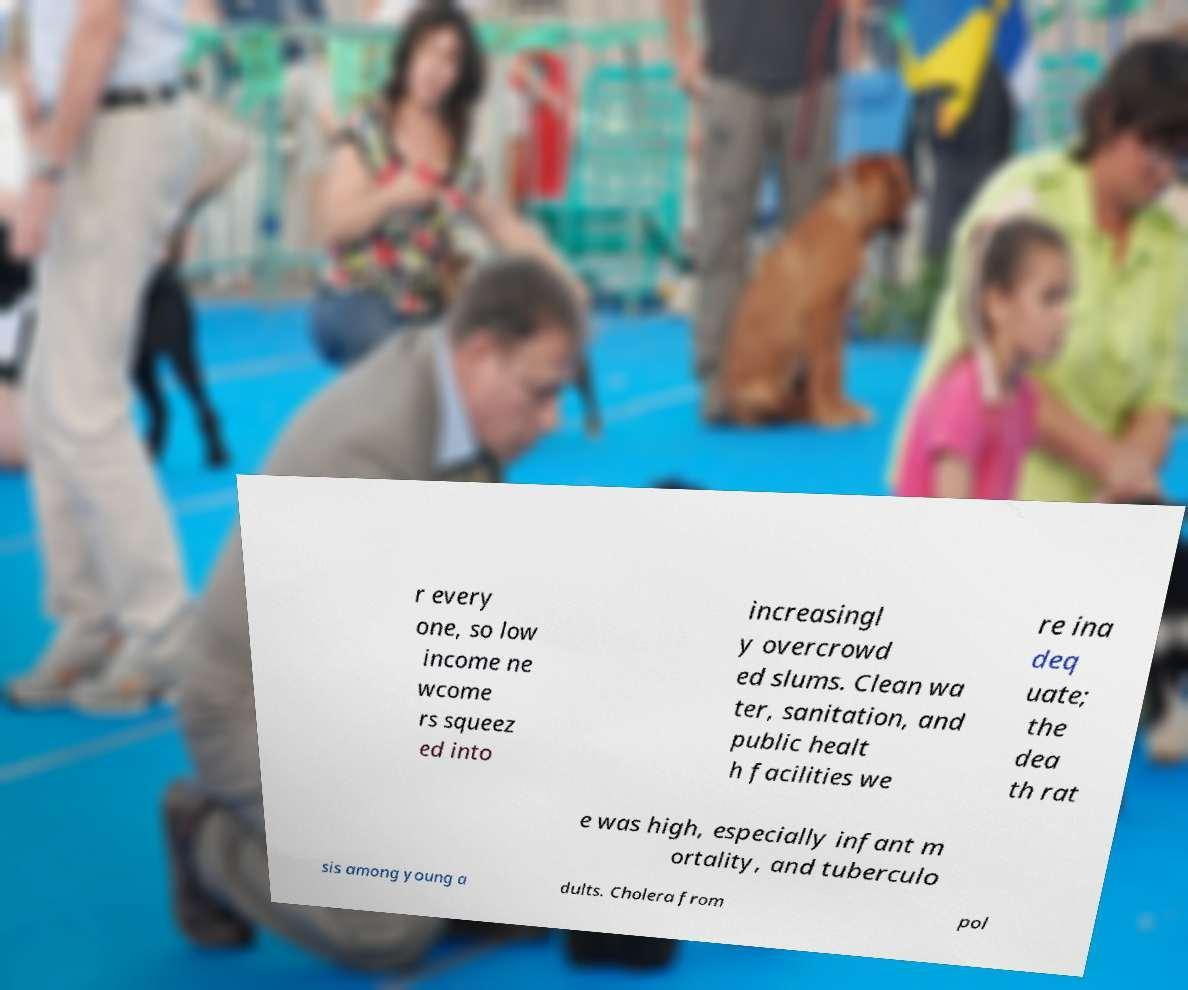For documentation purposes, I need the text within this image transcribed. Could you provide that? r every one, so low income ne wcome rs squeez ed into increasingl y overcrowd ed slums. Clean wa ter, sanitation, and public healt h facilities we re ina deq uate; the dea th rat e was high, especially infant m ortality, and tuberculo sis among young a dults. Cholera from pol 